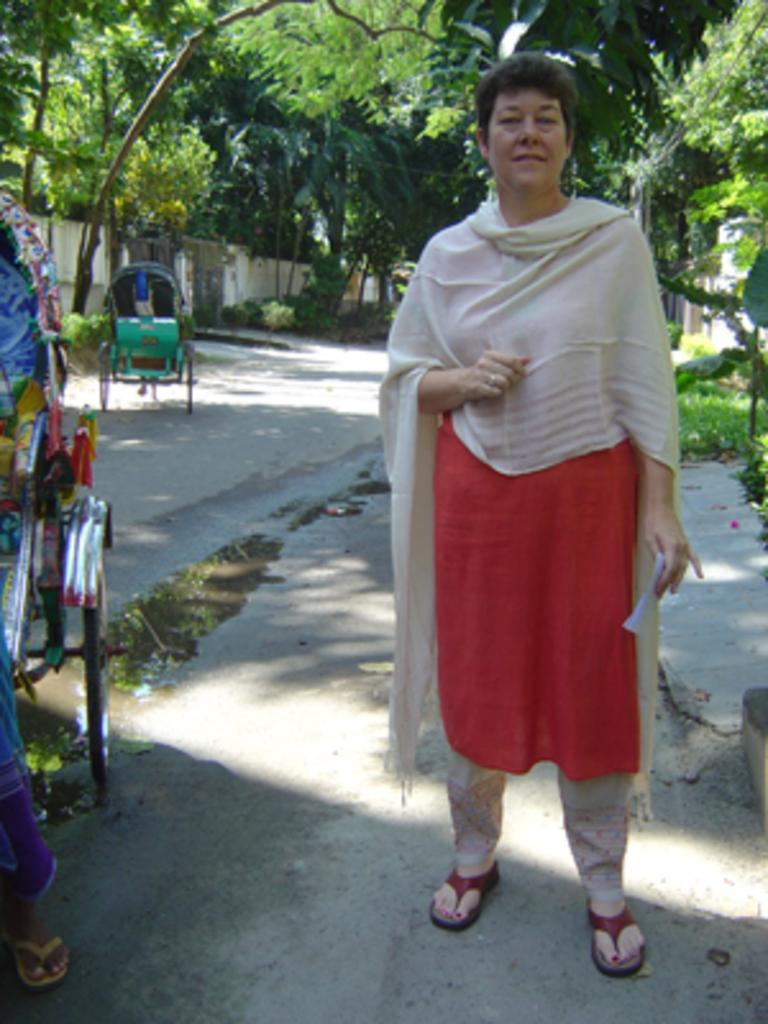In one or two sentences, can you explain what this image depicts? This picture is clicked outside. On the right there is a person holding a paper and standing on the ground. On the left we can see there are some vehicles placed on the ground. In the background there are some trees and plants. 